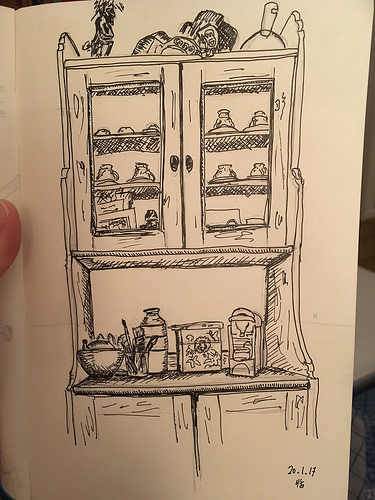<image>
Is there a hutch in front of the paper? No. The hutch is not in front of the paper. The spatial positioning shows a different relationship between these objects. 